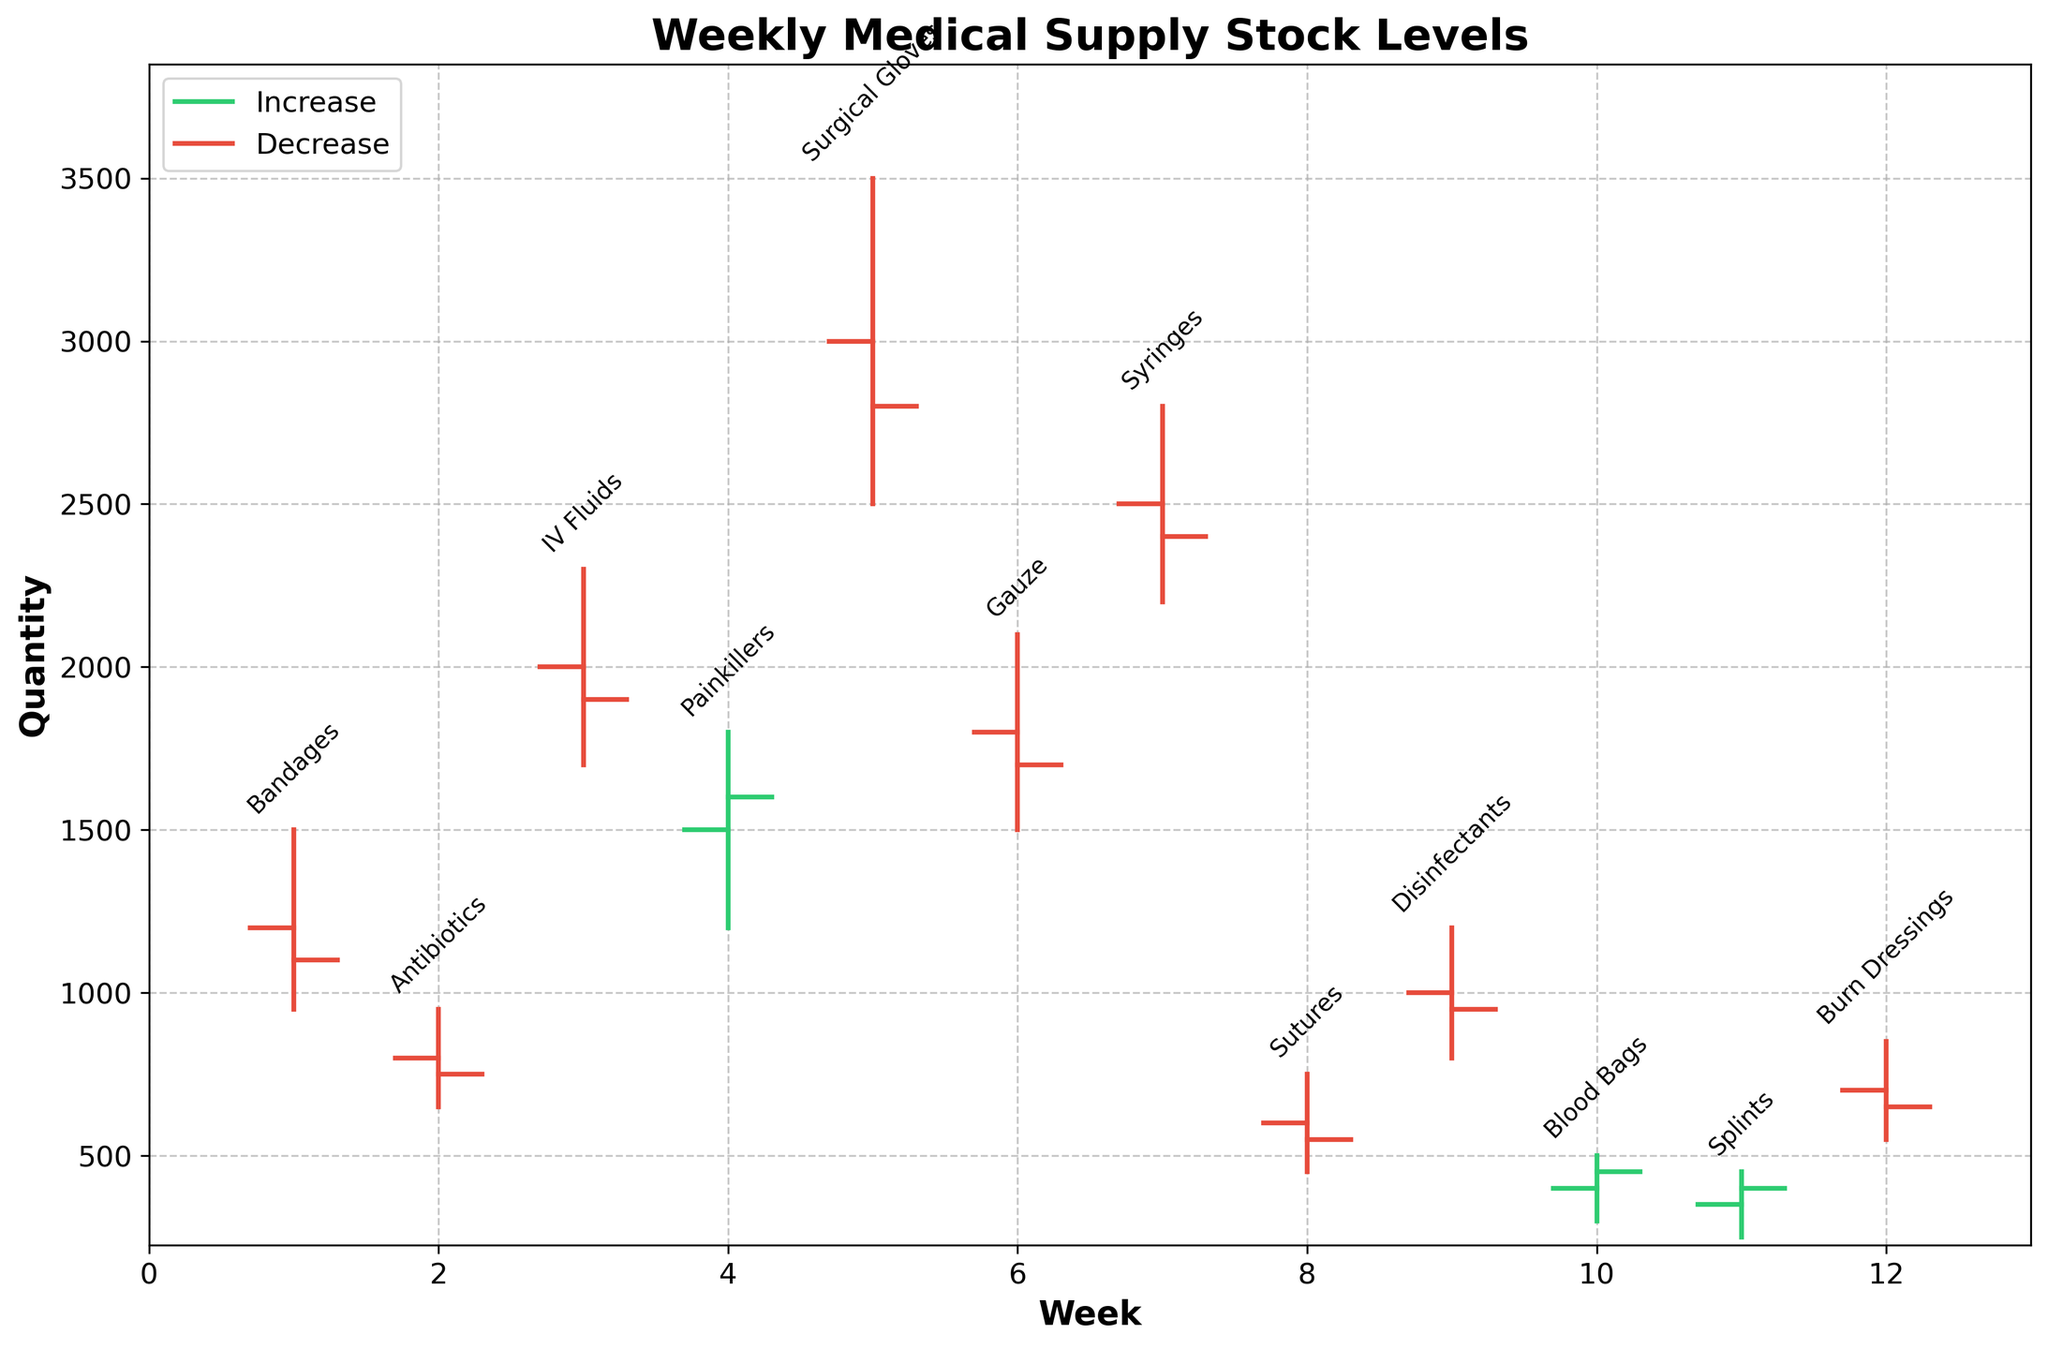What is the title of the chart? The title of the chart is found at the top center and describes the overall content of the figure thereby helping to understand the data being presented.
Answer: Weekly Medical Supply Stock Levels Which medical supply had the highest peak stock level? To determine this, examine the high values for each line representing different weeks. The highest peak value among all the supplies is identified.
Answer: Surgical Gloves What is the average closing stock for the first three weeks? Identify the closing values for the first three weeks (1100, 750, 1900) and compute the average: (1100 + 750 + 1900) / 3.
Answer: 1250 Which week had the greatest difference between high and low stock levels? Calculate the difference between high and low values for each week and find the week with the largest difference. The difference for each week is: 1: 550, 2: 300, 3: 600, 4: 600, 5: 1000, 6: 600, 7: 600, 8: 300, 9: 400, 10: 200, 11: 200, 12: 300.
Answer: Surgical Gloves (Week 5) Is the closing value for Burn Dressings higher or lower than its opening value? Compare the closing value (650) against the opening value (700) for Burn Dressings (Week 12).
Answer: Lower Which supply had the lowest closing stock level? Identify the smallest closing value among all the supplies. The lowest value among the closings is 450 (Sutures).
Answer: Sutures For which supply did the stock quantity increase over the week? Look for supplies where the closing value is greater than the opening value. These are indicated with a green color vertical line.
Answer: Bandages, Painkillers, Surgical Gloves, Syringes, Splints What are the high and low values for IV Fluids? Locate IV Fluids (Week 3) and note the high and low values, which are 2300 and 1700 respectively.
Answer: High: 2300, Low: 1700 Between Bandages and Antibiotics, which had a higher opening stock? Compare the opening stock value of Bandages (1500) and Antibiotics (950). The higher one is identified.
Answer: Bandages 